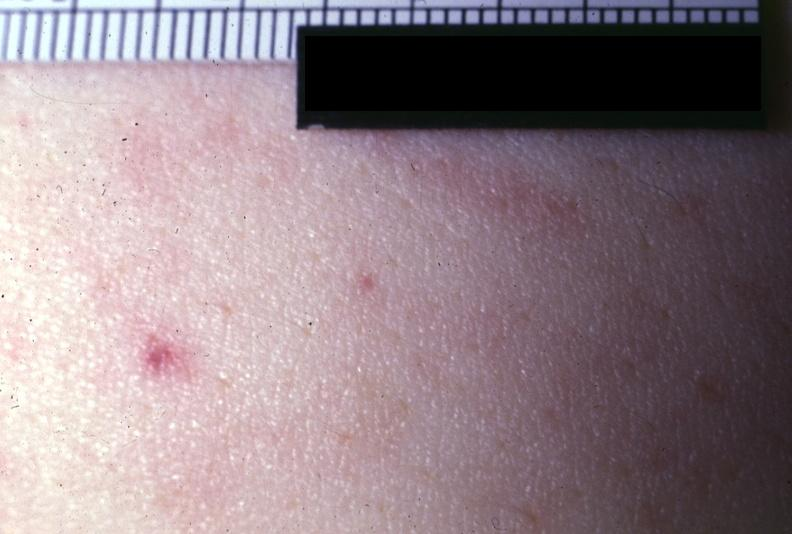does this image show close-up photo very good?
Answer the question using a single word or phrase. Yes 